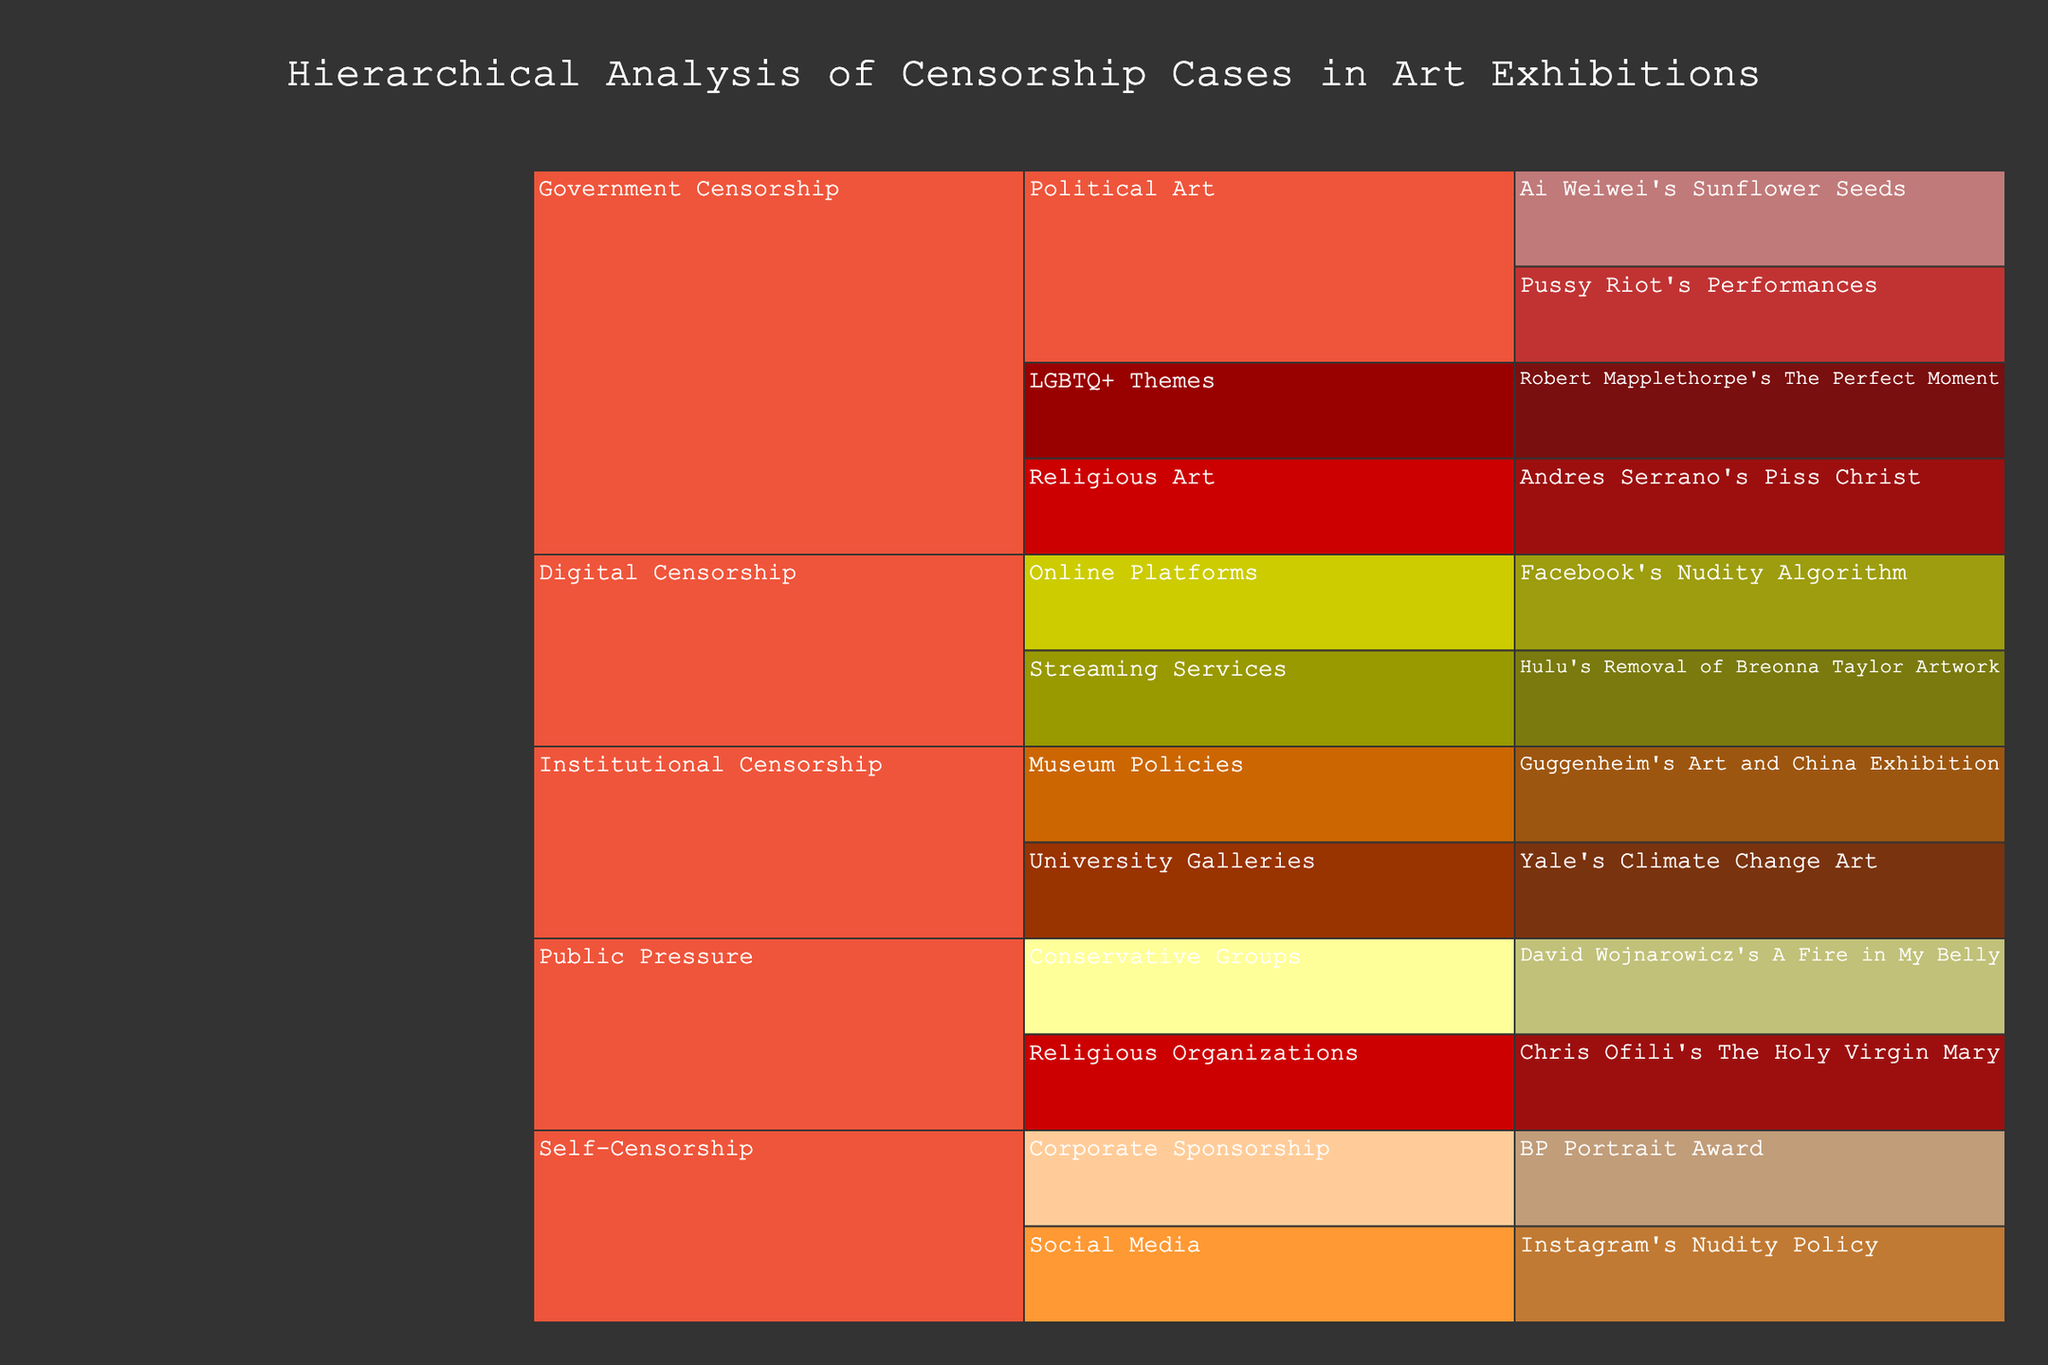What is the title of the chart? The title of the chart is located at the top center, it provides a summary of what the chart represents.
Answer: Hierarchical Analysis of Censorship Cases in Art Exhibitions What color represents 'Fully Censored' outcomes? Look for the icicle segments and their associated colors. 'Fully Censored' is represented by the color that matches the label in the legend.
Answer: Red Which case of self-censorship falls under the category of 'Social Media'? Find the 'Self-Censorship' category, then look at its subdivisions and locate 'Social Media' to identify the relevant case.
Answer: Instagram's Nudity Policy How many specific cases fall under 'Government Censorship'? Locate the 'Government Censorship' branch and count all its sub-branches that correspond to specific cases.
Answer: Four Which type of censorship has the most cases listed in the chart? Observe all the main categories at the top level and count the number of specific cases within each to determine the category with the highest count.
Answer: Government Censorship Between 'Government Censorship' and 'Public Pressure', which has more instances of 'Vandalized' outcomes? Identify 'Vandalized' outcomes within each category and compare the counts.
Answer: Government Censorship What is the outcome of 'The Holy Virgin Mary' by Chris Ofili? Locate the 'Public Pressure' category, then navigate to 'Religious Organizations' and find the specific case to see the outcome.
Answer: Vandalized How many instances of 'Content Removed' are present in digital censorship? Find the 'Digital Censorship' category, then locate and count the segments associated with 'Content Removed'.
Answer: Zero Are there more 'Online Platforms' cases or 'Streaming Services' cases under 'Digital Censorship'? Look at the branches under 'Digital Censorship' and count the specific cases in 'Online Platforms' and 'Streaming Services' to compare them.
Answer: Equal (One each) Which specific case under 'University Galleries' resulted in a removed controversial piece? Navigate to 'Institutional Censorship', then go to 'University Galleries' to find and identify the specific case with the outcome 'Removed Controversial Piece'.
Answer: Yale's Climate Change Art 